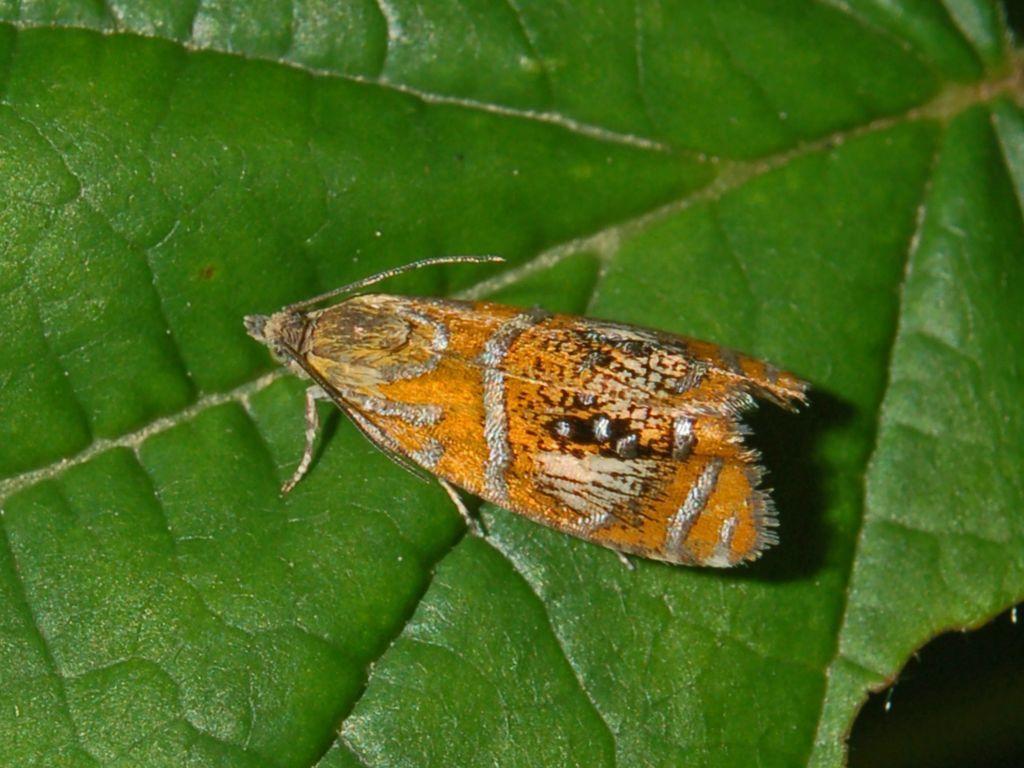How would you summarize this image in a sentence or two? In the center of the image we can see a fly on the leaf. 